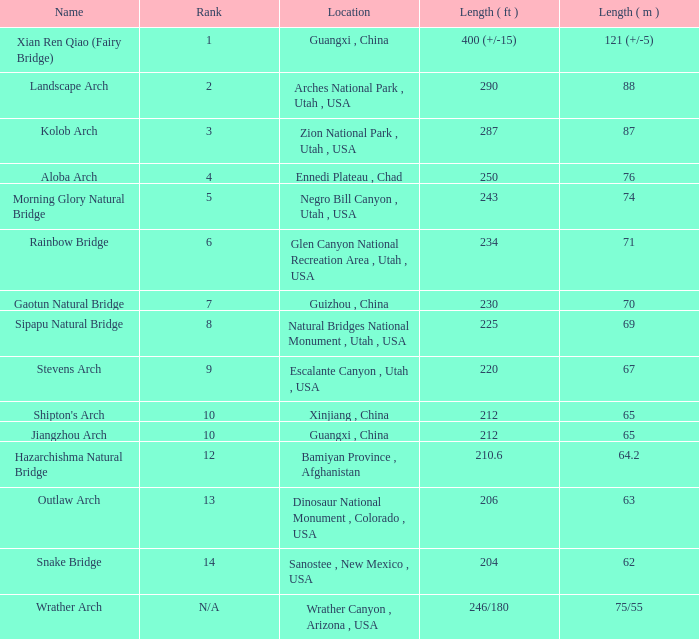What is the length in feet of the Jiangzhou arch? 212.0. 